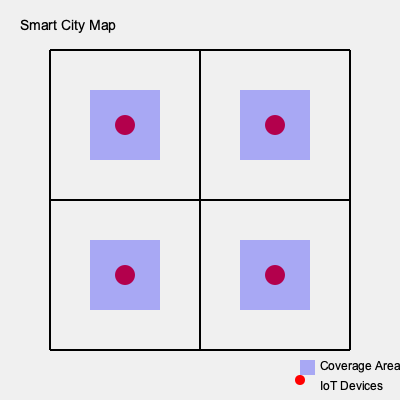In the smart city infrastructure depicted above, which privacy concern is most prominently illustrated by the placement and coverage of IoT devices? To answer this question, let's analyze the smart city map step-by-step:

1. Device placement: The map shows four IoT devices (red circles) placed at intersections of the city grid.

2. Coverage areas: Each device has a blue shaded area around it, representing its coverage or data collection range.

3. Overlap: The coverage areas of the devices overlap significantly, covering almost the entire mapped area of the city.

4. Comprehensive monitoring: The overlapping coverage suggests that nearly all public spaces within the mapped area are under constant surveillance or data collection.

5. Privacy implications: This comprehensive coverage raises concerns about:
   a) Ubiquitous surveillance: Citizens may be constantly monitored in public spaces.
   b) Data aggregation: Multiple devices collecting data on the same areas could lead to more detailed profiling of individuals.
   c) Lack of privacy zones: There are few to no areas within the city grid that are free from IoT device coverage.

6. Ethical considerations: This setup potentially infringes on citizens' right to privacy in public spaces and their ability to move about the city without constant digital tracking.

The most prominent privacy concern illustrated here is the potential for ubiquitous surveillance and tracking of citizens throughout the city due to the comprehensive and overlapping coverage of IoT devices.
Answer: Ubiquitous surveillance 